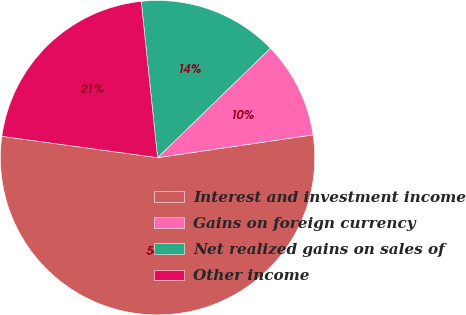<chart> <loc_0><loc_0><loc_500><loc_500><pie_chart><fcel>Interest and investment income<fcel>Gains on foreign currency<fcel>Net realized gains on sales of<fcel>Other income<nl><fcel>54.49%<fcel>9.94%<fcel>14.4%<fcel>21.17%<nl></chart> 